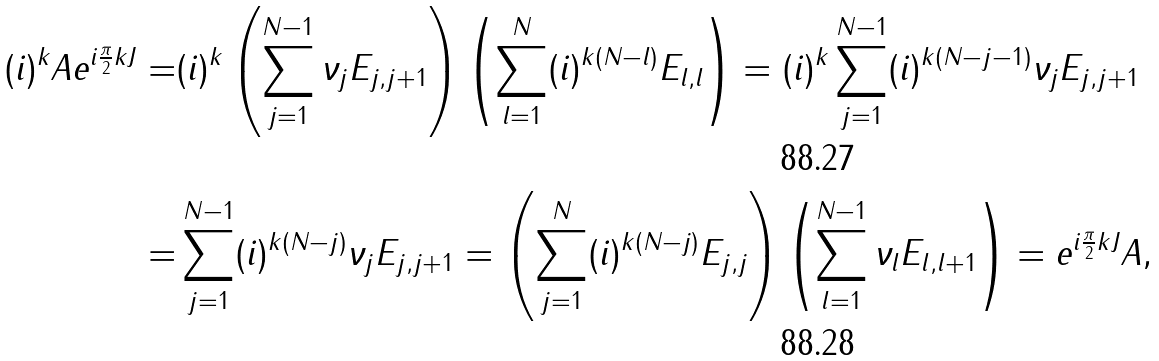Convert formula to latex. <formula><loc_0><loc_0><loc_500><loc_500>( i ) ^ { k } A e ^ { i \frac { \pi } { 2 } k J } = & ( i ) ^ { k } \left ( \sum _ { j = 1 } ^ { N - 1 } \nu _ { j } E _ { j , j + 1 } \right ) \left ( \sum _ { l = 1 } ^ { N } ( i ) ^ { k ( N - l ) } E _ { l , l } \right ) = ( i ) ^ { k } \sum _ { j = 1 } ^ { N - 1 } ( i ) ^ { k ( N - j - 1 ) } \nu _ { j } E _ { j , j + 1 } \\ = & \sum _ { j = 1 } ^ { N - 1 } ( i ) ^ { k ( N - j ) } \nu _ { j } E _ { j , j + 1 } = \left ( \sum _ { j = 1 } ^ { N } ( i ) ^ { k ( N - j ) } E _ { j , j } \right ) \left ( \sum _ { l = 1 } ^ { N - 1 } \nu _ { l } E _ { l , l + 1 } \right ) = e ^ { i \frac { \pi } { 2 } k J } A ,</formula> 